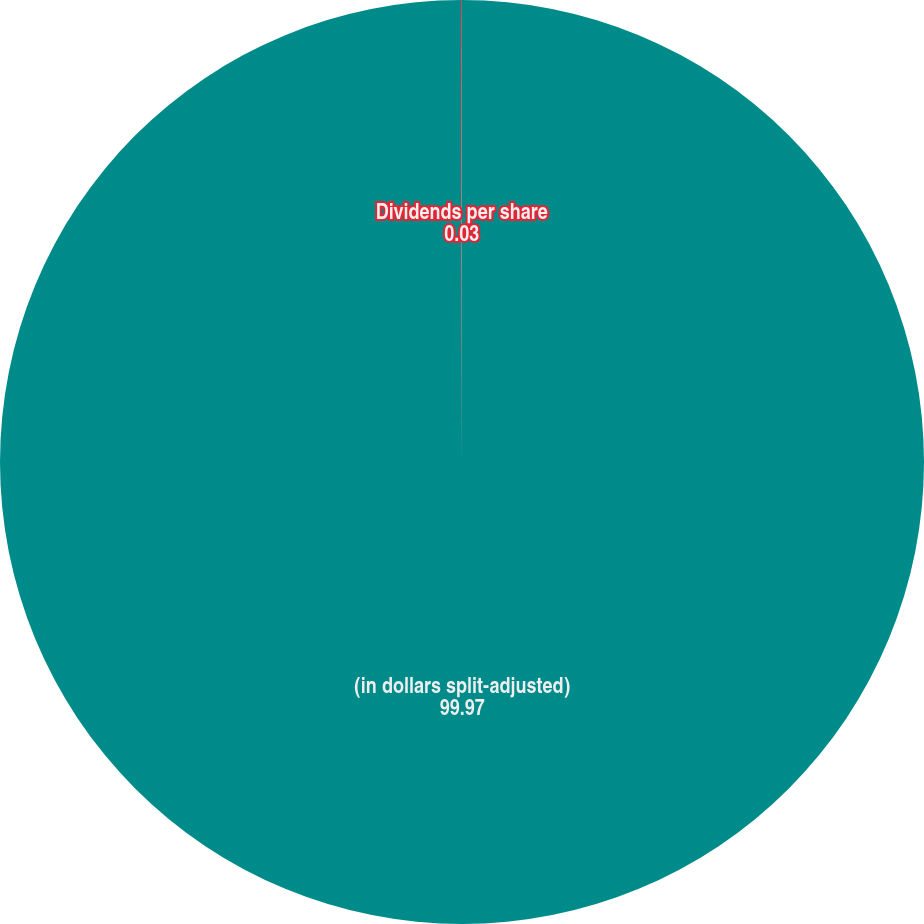Convert chart. <chart><loc_0><loc_0><loc_500><loc_500><pie_chart><fcel>(in dollars split-adjusted)<fcel>Dividends per share<nl><fcel>99.97%<fcel>0.03%<nl></chart> 